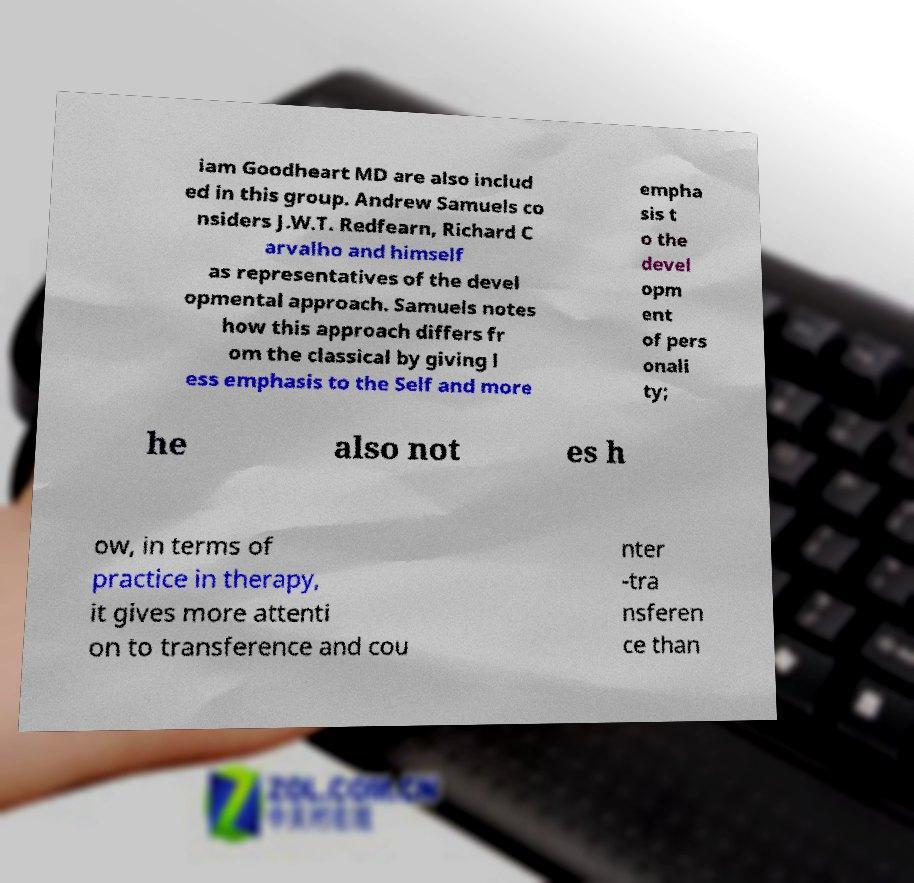Can you accurately transcribe the text from the provided image for me? iam Goodheart MD are also includ ed in this group. Andrew Samuels co nsiders J.W.T. Redfearn, Richard C arvalho and himself as representatives of the devel opmental approach. Samuels notes how this approach differs fr om the classical by giving l ess emphasis to the Self and more empha sis t o the devel opm ent of pers onali ty; he also not es h ow, in terms of practice in therapy, it gives more attenti on to transference and cou nter -tra nsferen ce than 